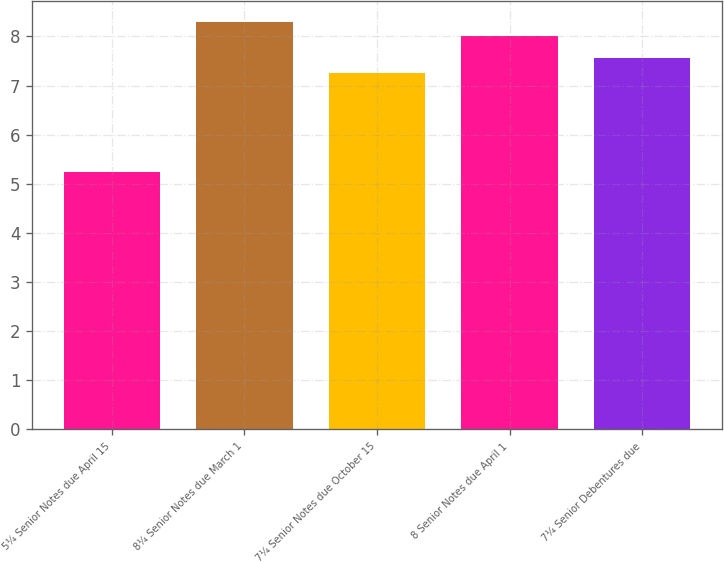Convert chart. <chart><loc_0><loc_0><loc_500><loc_500><bar_chart><fcel>5¼ Senior Notes due April 15<fcel>8¼ Senior Notes due March 1<fcel>7¼ Senior Notes due October 15<fcel>8 Senior Notes due April 1<fcel>7¼ Senior Debentures due<nl><fcel>5.25<fcel>8.3<fcel>7.25<fcel>8<fcel>7.55<nl></chart> 